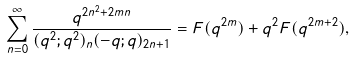Convert formula to latex. <formula><loc_0><loc_0><loc_500><loc_500>\sum _ { n = 0 } ^ { \infty } \frac { q ^ { 2 n ^ { 2 } + 2 m n } } { ( q ^ { 2 } ; q ^ { 2 } ) _ { n } ( - q ; q ) _ { 2 n + 1 } } = F ( q ^ { 2 m } ) + q ^ { 2 } F ( q ^ { 2 m + 2 } ) ,</formula> 